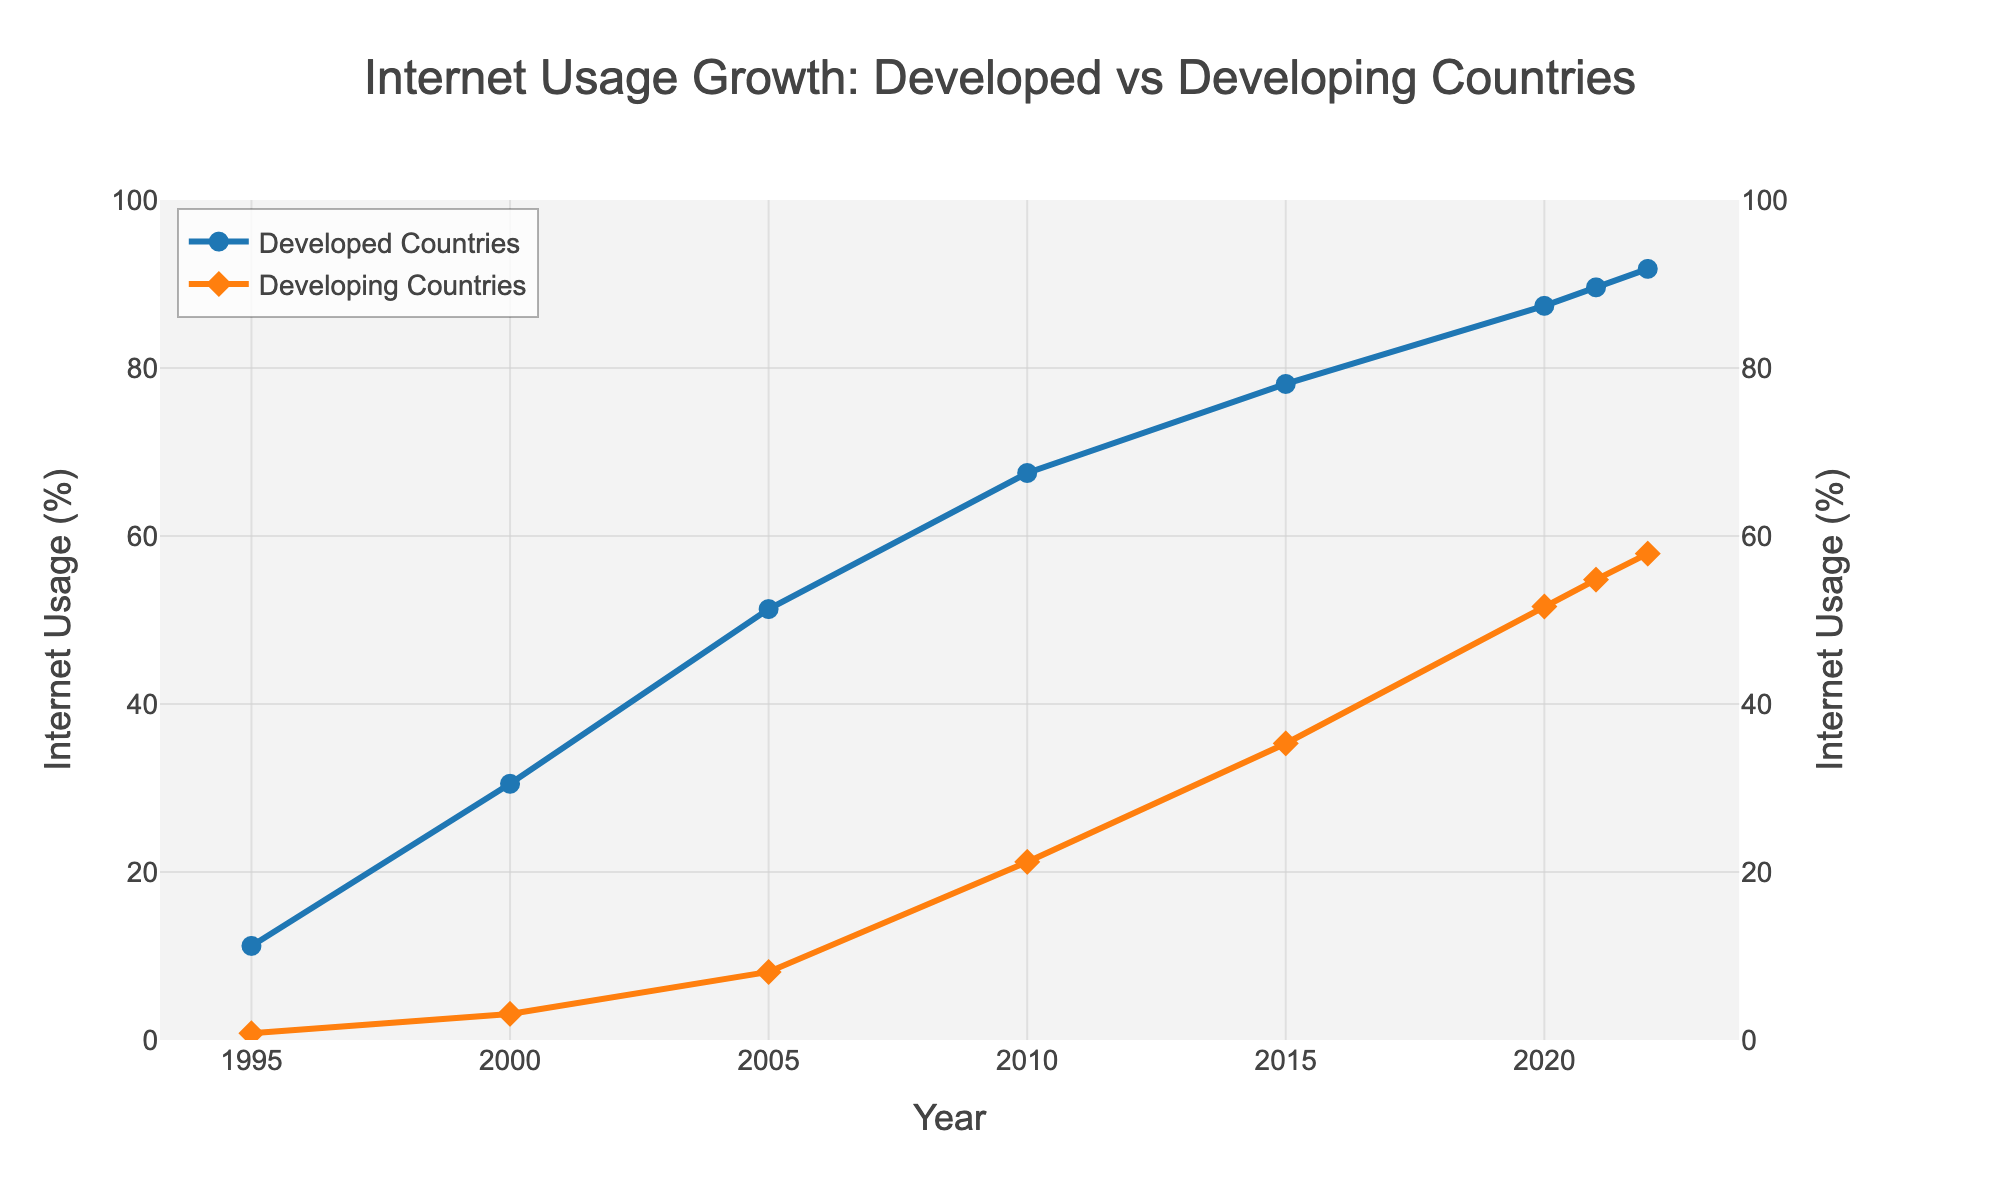What trend can you observe for Internet usage in developed countries from 1995 to 2022? To determine the trend, look at the percentage points for developed countries over the years on the line chart. The line consistently moves upwards from 11.2% in 1995 to 91.8% in 2022, indicating a steady increase in Internet usage.
Answer: Steady increase In which year did developing countries see the most significant increase in Internet usage percentage compared to the previous year? Examine the line graph for developing countries and check the percentage increase year over year. The most significant increase can be observed between 2005 (8.1%) and 2010 (21.2%), which is 13.1 percentage points.
Answer: 2010 How does the Internet usage percentage in developing countries in 2022 compare to that in developed countries in 1995? Compare the percentage points for developing countries in 2022 and developed countries in 1995 from the figure. In 2022, developing countries have 57.9%, whereas developed countries had 11.2% in 1995, indicating a higher usage in developing countries in 2022.
Answer: Much higher What is the difference in Internet usage percentage between developed and developing countries in 2022? Subtract the Internet usage percentage of developing countries from that of developed countries for the year 2022. That is 91.8% - 57.9%.
Answer: 33.9% Estimate the average annual growth rate of Internet usage in developing countries between 1995 and 2005. Calculate the difference in usage percentage between 1995 and 2005 (8.1% - 0.8%) and divide it by the number of years (10), which is approximately 0.73% per year.
Answer: 0.73% per year In 2000, how much higher was the Internet usage in developed countries compared to developing countries in percentage terms? Subtract the Internet usage percentage of developing countries from that of developed countries for the year 2000. That is 30.5% - 3.1%.
Answer: 27.4% Which country group had a linear or more consistent increase in Internet usage over the years? Observe the lines’ shapes for each country group. The developed countries' line shows a consistent upward trend, whereas the developing countries' line shows some rapid increases in certain periods.
Answer: Developed countries What colors represent developed and developing countries in the chart? Refer to the colors of the lines representing each country group in the chart description. The developed countries are represented by blue, and developing countries by orange.
Answer: Blue and orange 